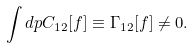Convert formula to latex. <formula><loc_0><loc_0><loc_500><loc_500>\int d { p } C _ { 1 2 } [ f ] \equiv \Gamma _ { 1 2 } [ f ] \neq 0 .</formula> 